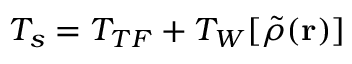<formula> <loc_0><loc_0><loc_500><loc_500>T _ { s } = T _ { T F } + T _ { W } [ \tilde { \rho } ( r ) ]</formula> 